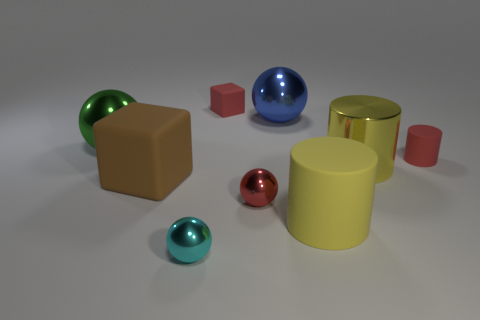Is the number of brown rubber cubes that are on the right side of the tiny red rubber block less than the number of big purple matte objects?
Provide a short and direct response. No. Does the large thing in front of the brown matte block have the same shape as the cyan thing?
Provide a succinct answer. No. Is there anything else that has the same color as the tiny rubber cube?
Give a very brief answer. Yes. What size is the red block that is made of the same material as the red cylinder?
Offer a very short reply. Small. There is a big ball that is left of the large shiny sphere that is on the right side of the tiny matte object behind the small red matte cylinder; what is its material?
Offer a terse response. Metal. Are there fewer red cubes than tiny red things?
Keep it short and to the point. Yes. Is the big green sphere made of the same material as the big cube?
Offer a very short reply. No. The rubber object that is the same color as the small rubber block is what shape?
Offer a terse response. Cylinder. Do the tiny metal object behind the tiny cyan ball and the small cylinder have the same color?
Offer a very short reply. Yes. How many brown things are right of the matte cube to the left of the small cyan shiny ball?
Offer a terse response. 0. 